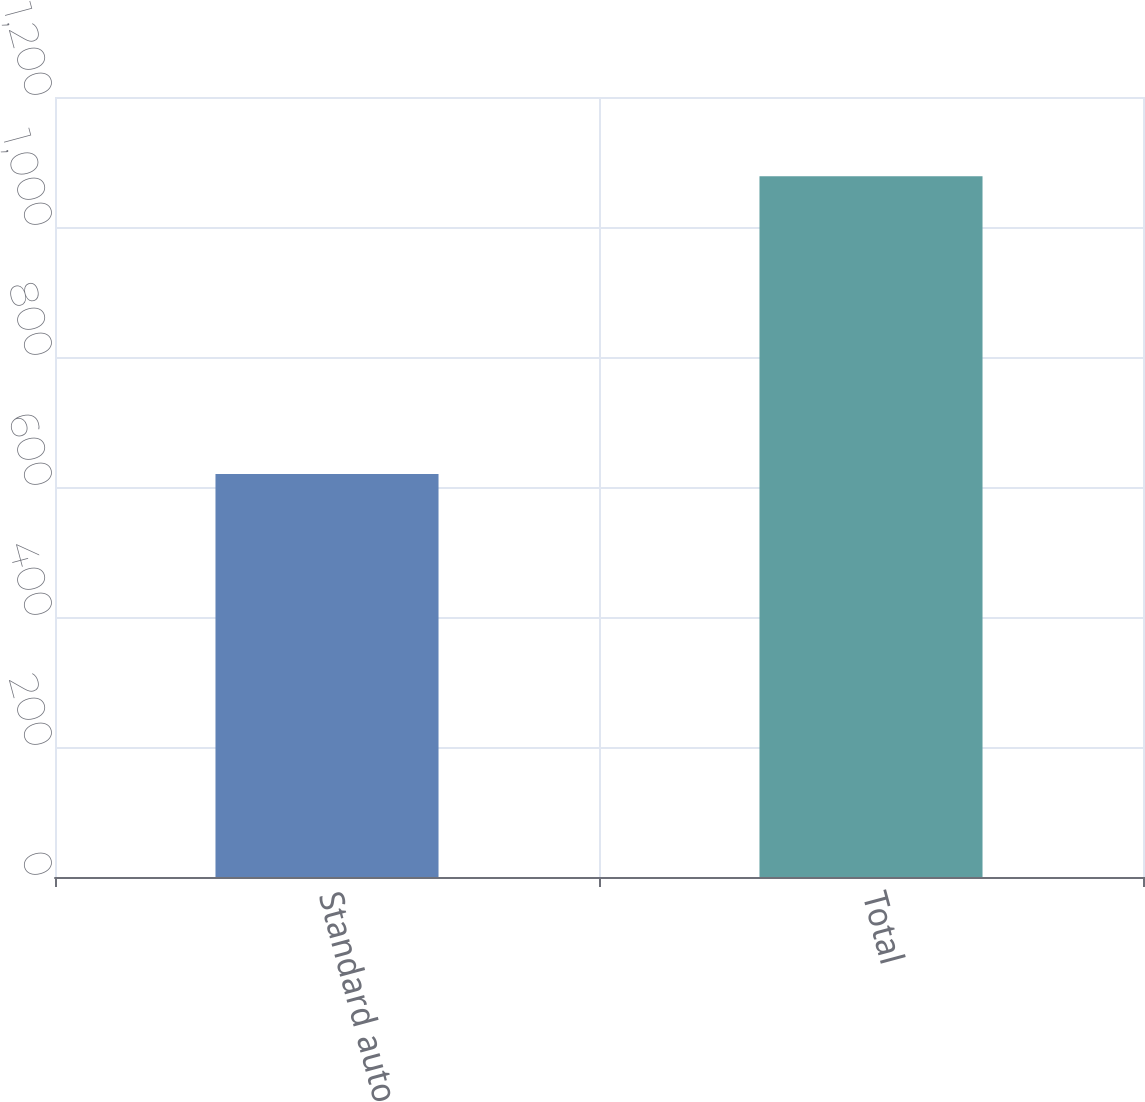Convert chart to OTSL. <chart><loc_0><loc_0><loc_500><loc_500><bar_chart><fcel>Standard auto<fcel>Total<nl><fcel>620<fcel>1078<nl></chart> 